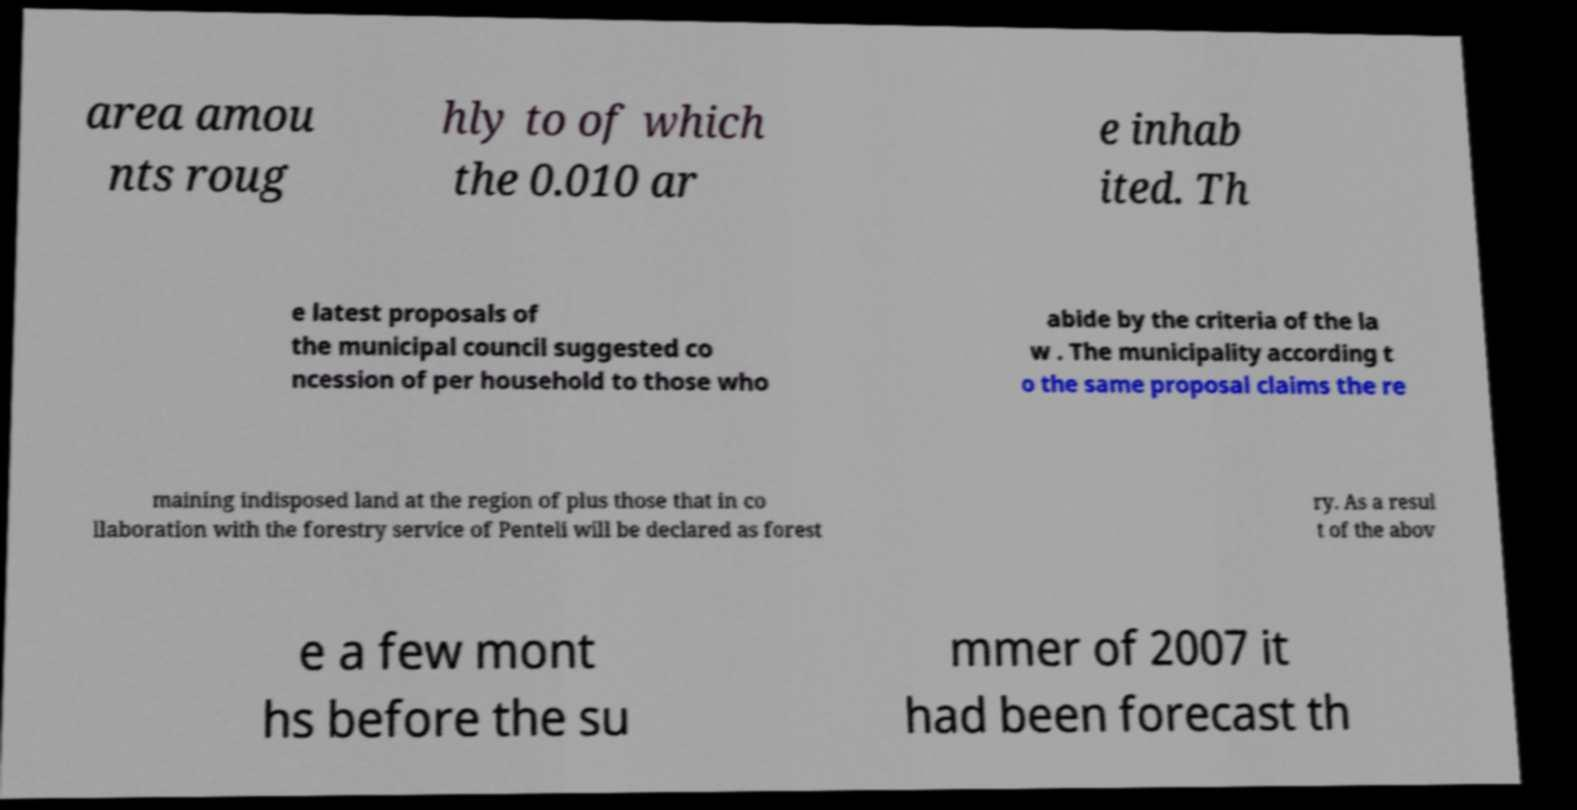Please read and relay the text visible in this image. What does it say? area amou nts roug hly to of which the 0.010 ar e inhab ited. Th e latest proposals of the municipal council suggested co ncession of per household to those who abide by the criteria of the la w . The municipality according t o the same proposal claims the re maining indisposed land at the region of plus those that in co llaboration with the forestry service of Penteli will be declared as forest ry. As a resul t of the abov e a few mont hs before the su mmer of 2007 it had been forecast th 